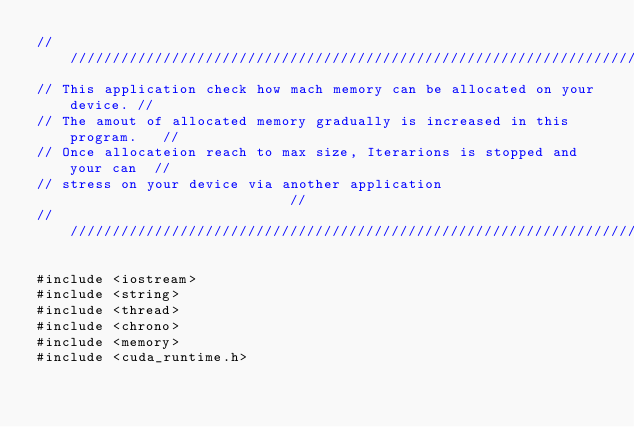<code> <loc_0><loc_0><loc_500><loc_500><_Cuda_>/////////////////////////////////////////////////////////////////////////////
// This application check how mach memory can be allocated on your device. //
// The amout of allocated memory gradually is increased in this program.   //
// Once allocateion reach to max size, Iterarions is stopped and your can  //
// stress on your device via another application                           //
/////////////////////////////////////////////////////////////////////////////

#include <iostream>
#include <string>
#include <thread>
#include <chrono>
#include <memory>
#include <cuda_runtime.h></code> 